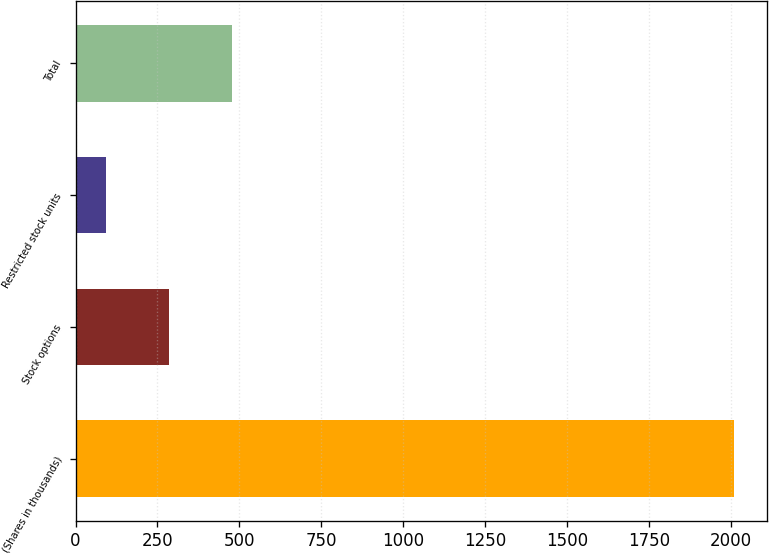Convert chart. <chart><loc_0><loc_0><loc_500><loc_500><bar_chart><fcel>(Shares in thousands)<fcel>Stock options<fcel>Restricted stock units<fcel>Total<nl><fcel>2011<fcel>285.7<fcel>94<fcel>477.4<nl></chart> 